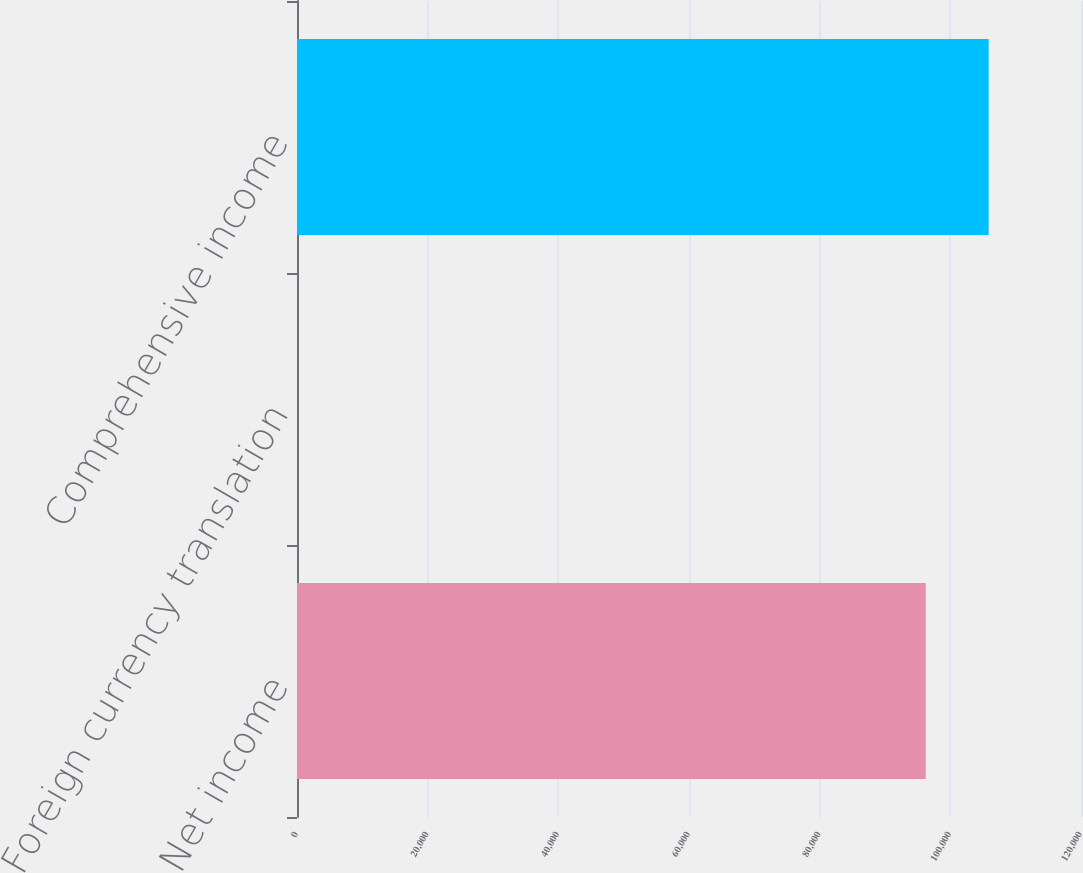<chart> <loc_0><loc_0><loc_500><loc_500><bar_chart><fcel>Net income<fcel>Foreign currency translation<fcel>Comprehensive income<nl><fcel>96241<fcel>22<fcel>105865<nl></chart> 